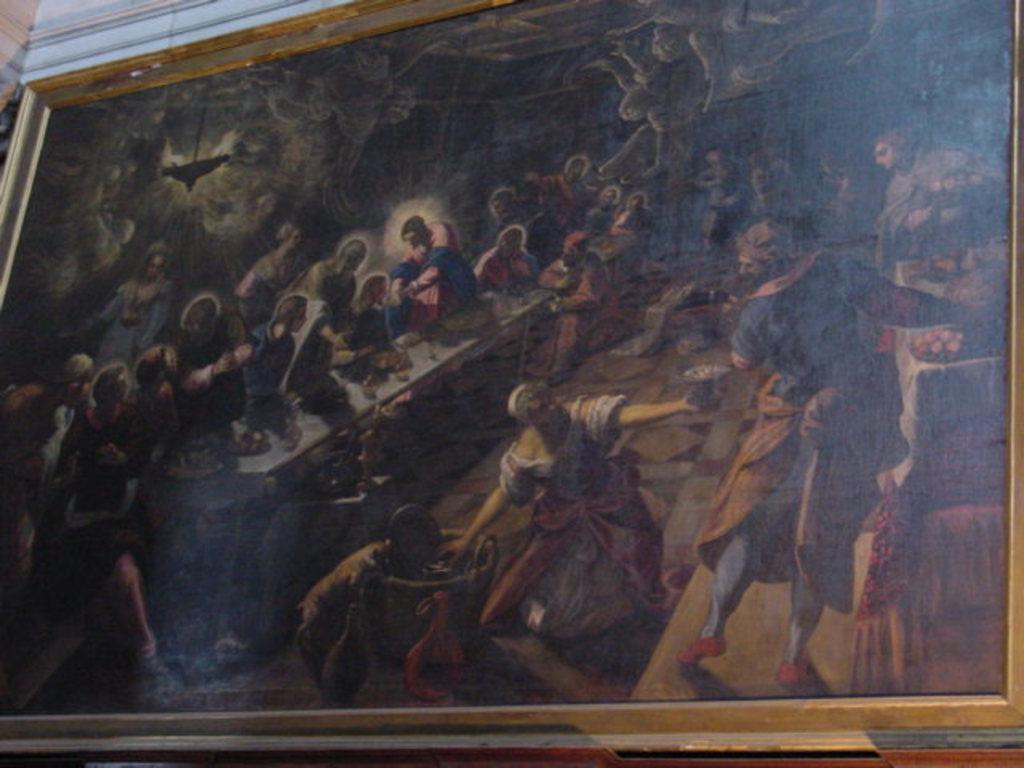What is hanging on the wall in the image? There is a frame on the wall in the image. What can be seen within the frame? There are people visible within the frame. Are there any plants growing near the frame in the image? There is no mention of plants in the image, so we cannot determine if there are any growing near the frame. 